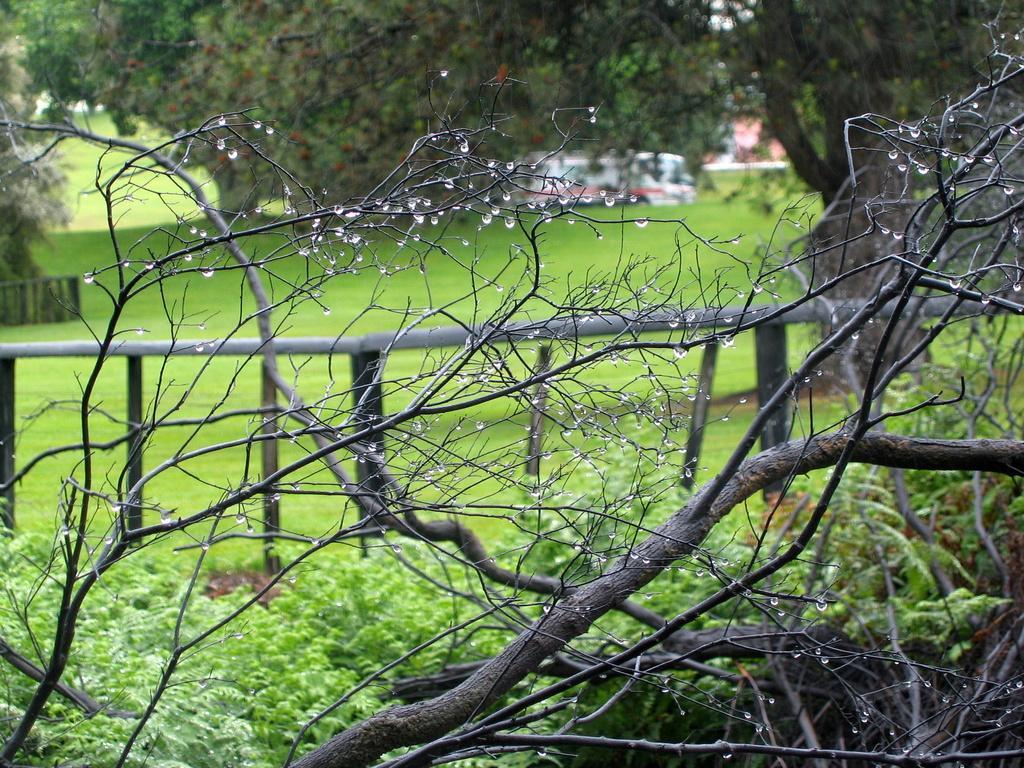Could you give a brief overview of what you see in this image? In this picture we can see grass here, at the bottom there are some plants, in the background we can see trees, there is some wood here. 